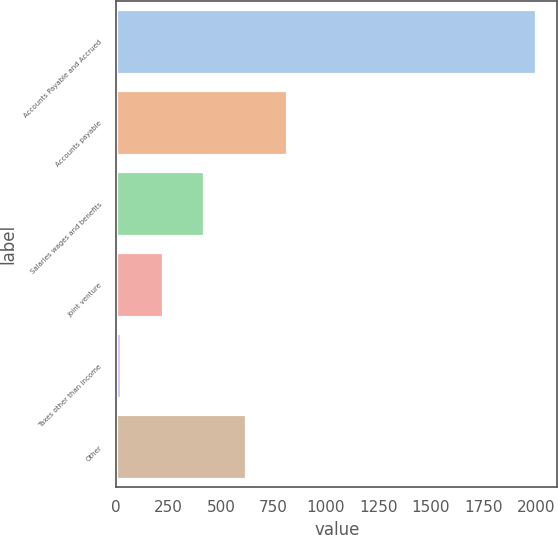<chart> <loc_0><loc_0><loc_500><loc_500><bar_chart><fcel>Accounts Payable and Accrued<fcel>Accounts payable<fcel>Salaries wages and benefits<fcel>Joint venture<fcel>Taxes other than income<fcel>Other<nl><fcel>2003<fcel>815.48<fcel>419.64<fcel>221.72<fcel>23.8<fcel>617.56<nl></chart> 